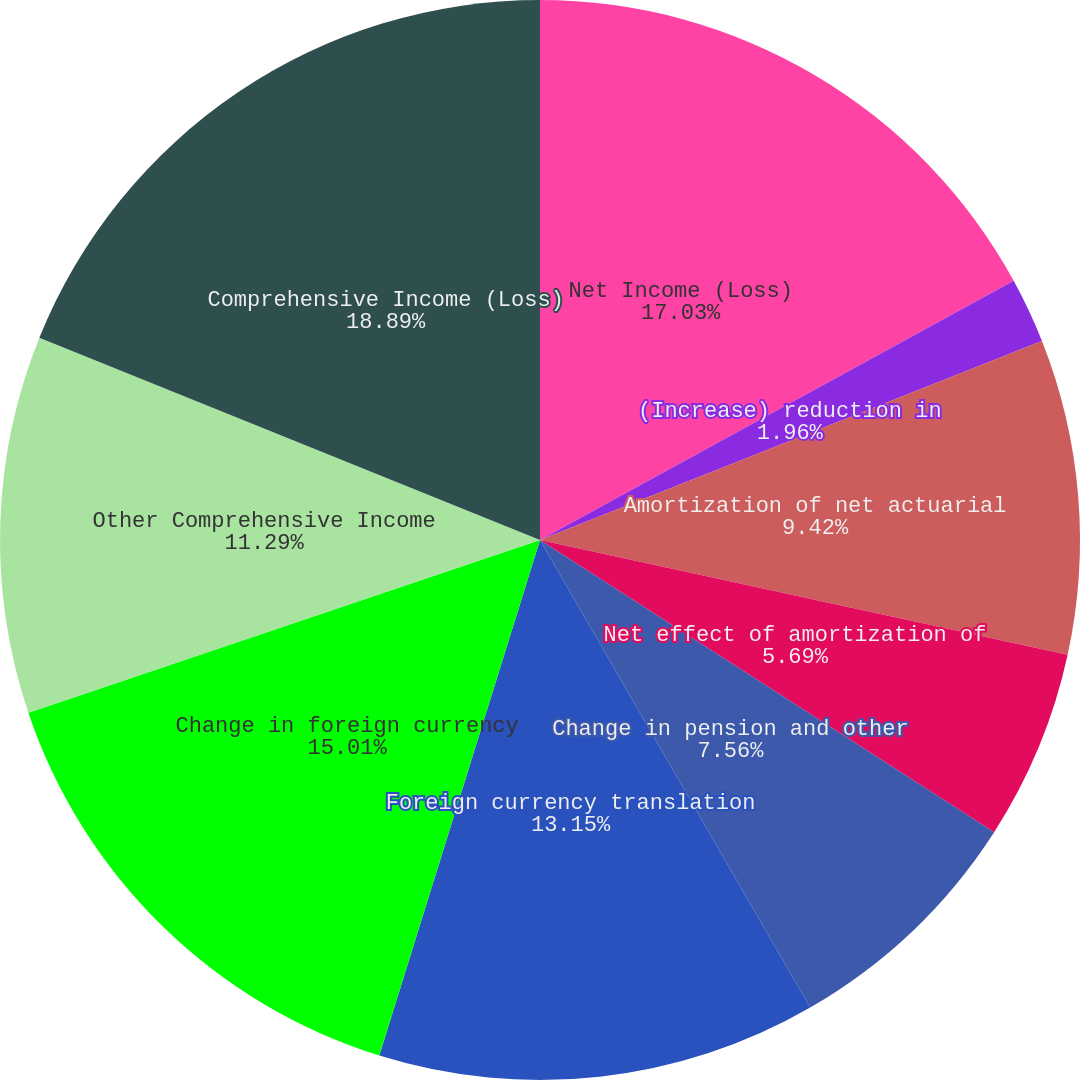<chart> <loc_0><loc_0><loc_500><loc_500><pie_chart><fcel>Net Income (Loss)<fcel>(Increase) reduction in<fcel>Amortization of net actuarial<fcel>Net effect of amortization of<fcel>Change in pension and other<fcel>Foreign currency translation<fcel>Change in foreign currency<fcel>Other Comprehensive Income<fcel>Comprehensive Income (Loss)<nl><fcel>17.03%<fcel>1.96%<fcel>9.42%<fcel>5.69%<fcel>7.56%<fcel>13.15%<fcel>15.01%<fcel>11.29%<fcel>18.89%<nl></chart> 